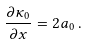Convert formula to latex. <formula><loc_0><loc_0><loc_500><loc_500>\frac { \partial \kappa _ { 0 } } { \partial x } = 2 a _ { 0 } \, .</formula> 